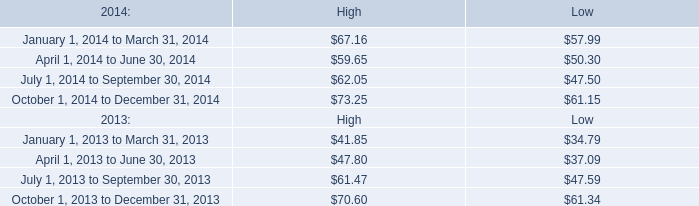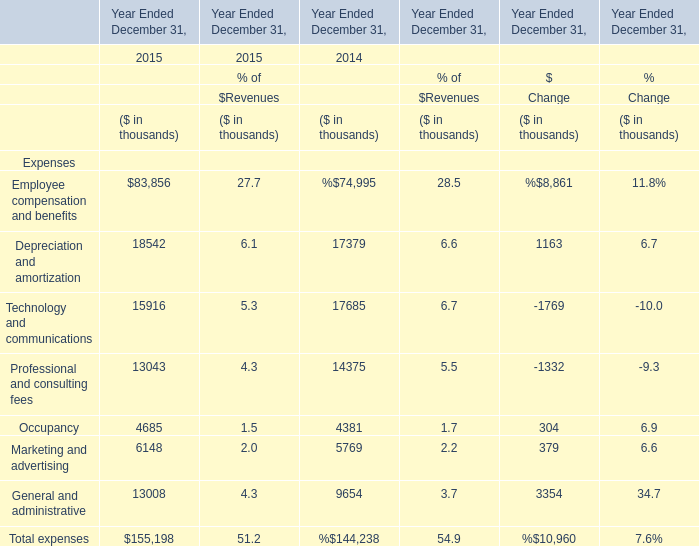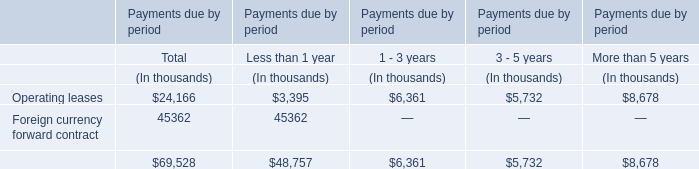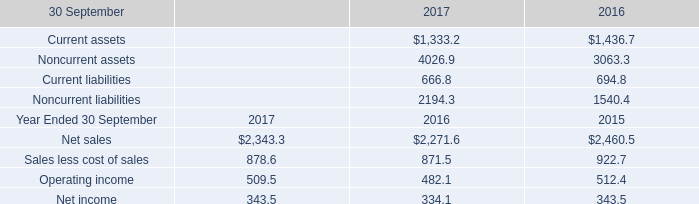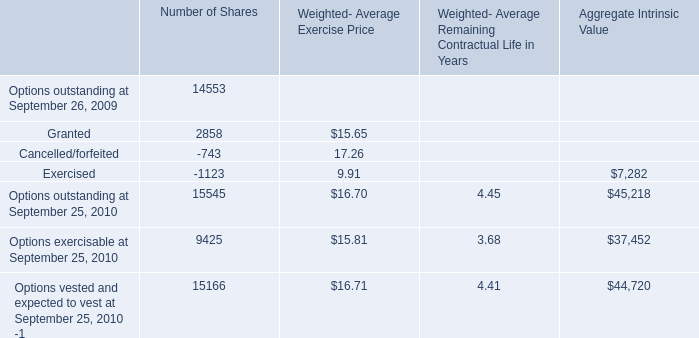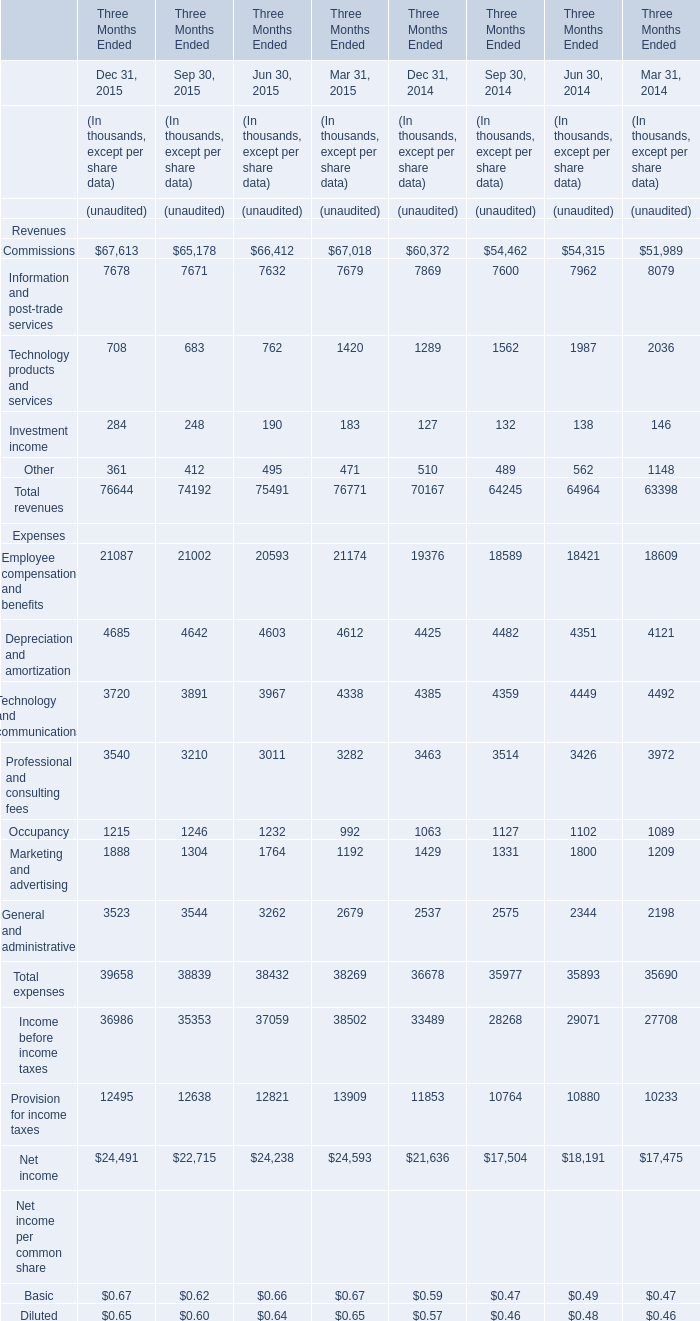In the year with the most Commissions, what is the growth rate of Technology products and services ? (in %) 
Computations: ((708 - 1289) / 1289)
Answer: -0.45074. 